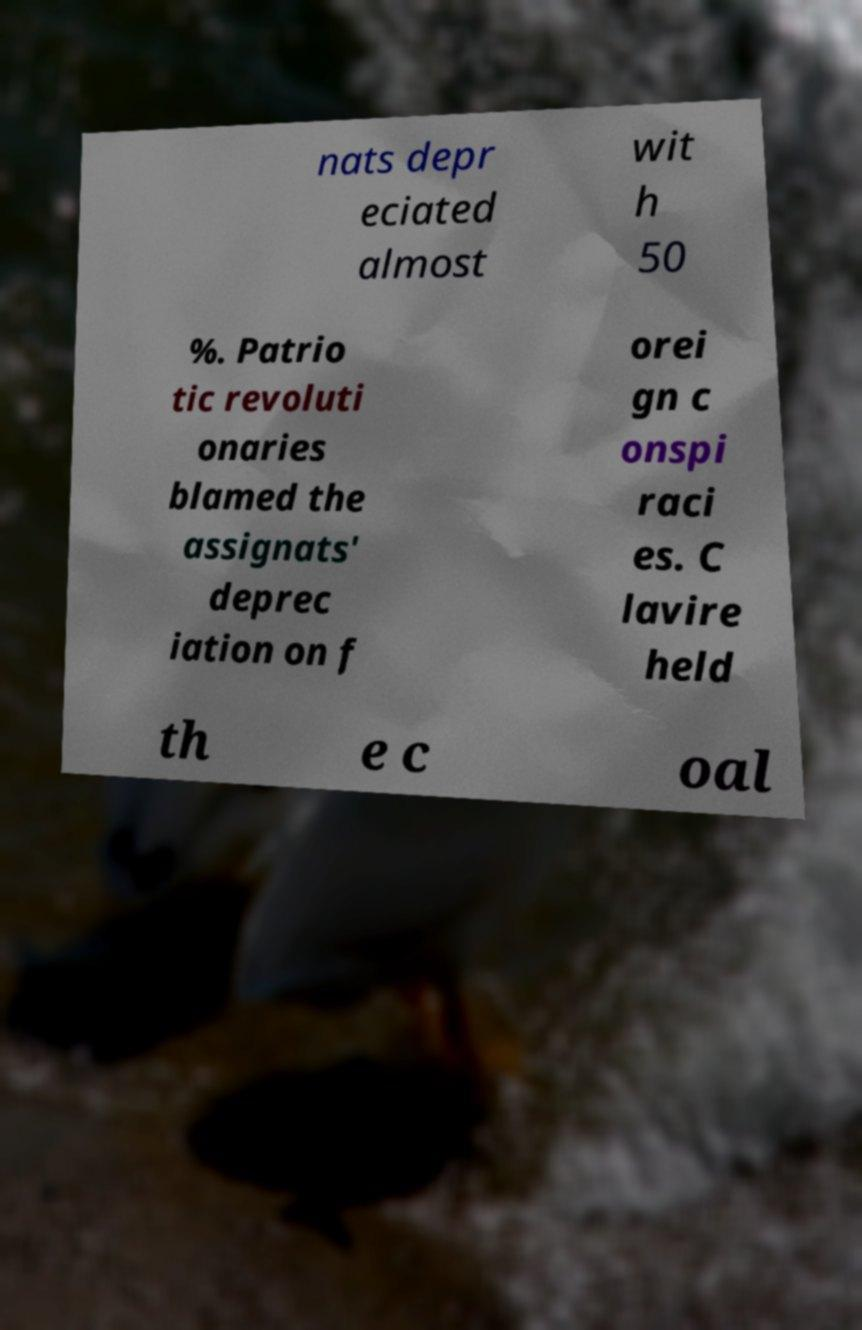What messages or text are displayed in this image? I need them in a readable, typed format. nats depr eciated almost wit h 50 %. Patrio tic revoluti onaries blamed the assignats' deprec iation on f orei gn c onspi raci es. C lavire held th e c oal 